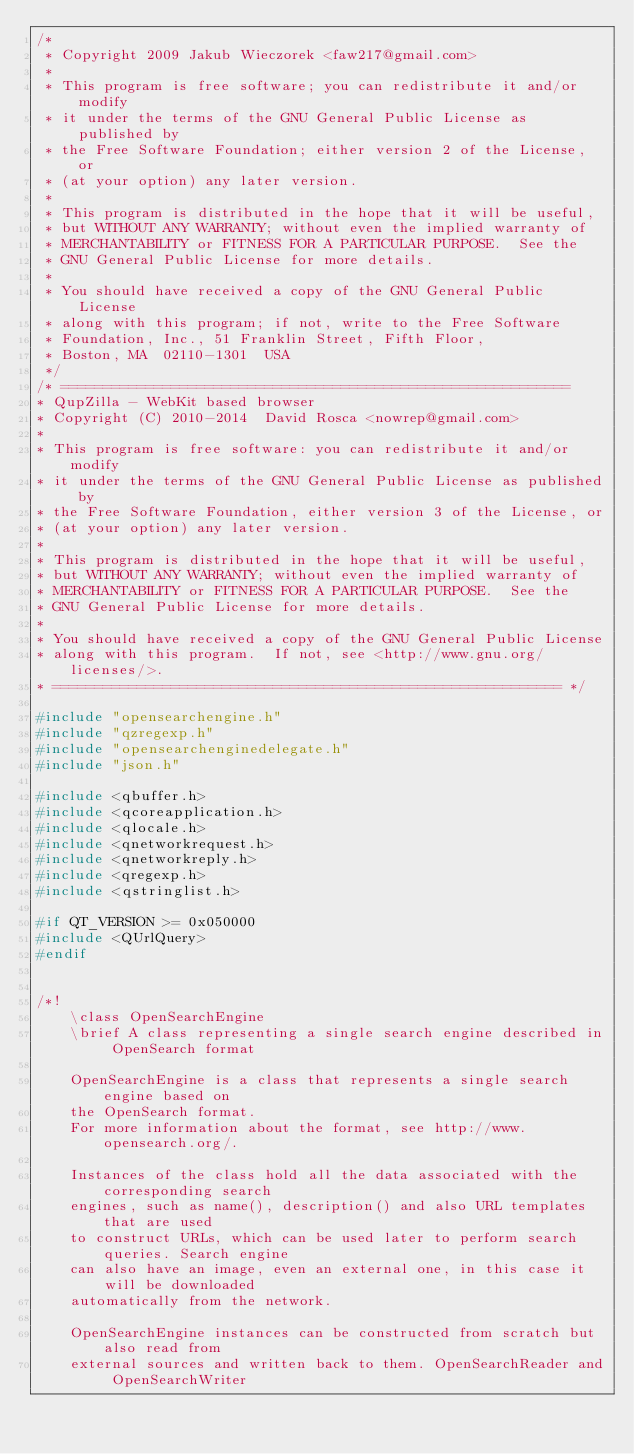<code> <loc_0><loc_0><loc_500><loc_500><_C++_>/*
 * Copyright 2009 Jakub Wieczorek <faw217@gmail.com>
 *
 * This program is free software; you can redistribute it and/or modify
 * it under the terms of the GNU General Public License as published by
 * the Free Software Foundation; either version 2 of the License, or
 * (at your option) any later version.
 *
 * This program is distributed in the hope that it will be useful,
 * but WITHOUT ANY WARRANTY; without even the implied warranty of
 * MERCHANTABILITY or FITNESS FOR A PARTICULAR PURPOSE.  See the
 * GNU General Public License for more details.
 *
 * You should have received a copy of the GNU General Public License
 * along with this program; if not, write to the Free Software
 * Foundation, Inc., 51 Franklin Street, Fifth Floor,
 * Boston, MA  02110-1301  USA
 */
/* ============================================================
* QupZilla - WebKit based browser
* Copyright (C) 2010-2014  David Rosca <nowrep@gmail.com>
*
* This program is free software: you can redistribute it and/or modify
* it under the terms of the GNU General Public License as published by
* the Free Software Foundation, either version 3 of the License, or
* (at your option) any later version.
*
* This program is distributed in the hope that it will be useful,
* but WITHOUT ANY WARRANTY; without even the implied warranty of
* MERCHANTABILITY or FITNESS FOR A PARTICULAR PURPOSE.  See the
* GNU General Public License for more details.
*
* You should have received a copy of the GNU General Public License
* along with this program.  If not, see <http://www.gnu.org/licenses/>.
* ============================================================ */

#include "opensearchengine.h"
#include "qzregexp.h"
#include "opensearchenginedelegate.h"
#include "json.h"

#include <qbuffer.h>
#include <qcoreapplication.h>
#include <qlocale.h>
#include <qnetworkrequest.h>
#include <qnetworkreply.h>
#include <qregexp.h>
#include <qstringlist.h>

#if QT_VERSION >= 0x050000
#include <QUrlQuery>
#endif


/*!
    \class OpenSearchEngine
    \brief A class representing a single search engine described in OpenSearch format

    OpenSearchEngine is a class that represents a single search engine based on
    the OpenSearch format.
    For more information about the format, see http://www.opensearch.org/.

    Instances of the class hold all the data associated with the corresponding search
    engines, such as name(), description() and also URL templates that are used
    to construct URLs, which can be used later to perform search queries. Search engine
    can also have an image, even an external one, in this case it will be downloaded
    automatically from the network.

    OpenSearchEngine instances can be constructed from scratch but also read from
    external sources and written back to them. OpenSearchReader and OpenSearchWriter</code> 